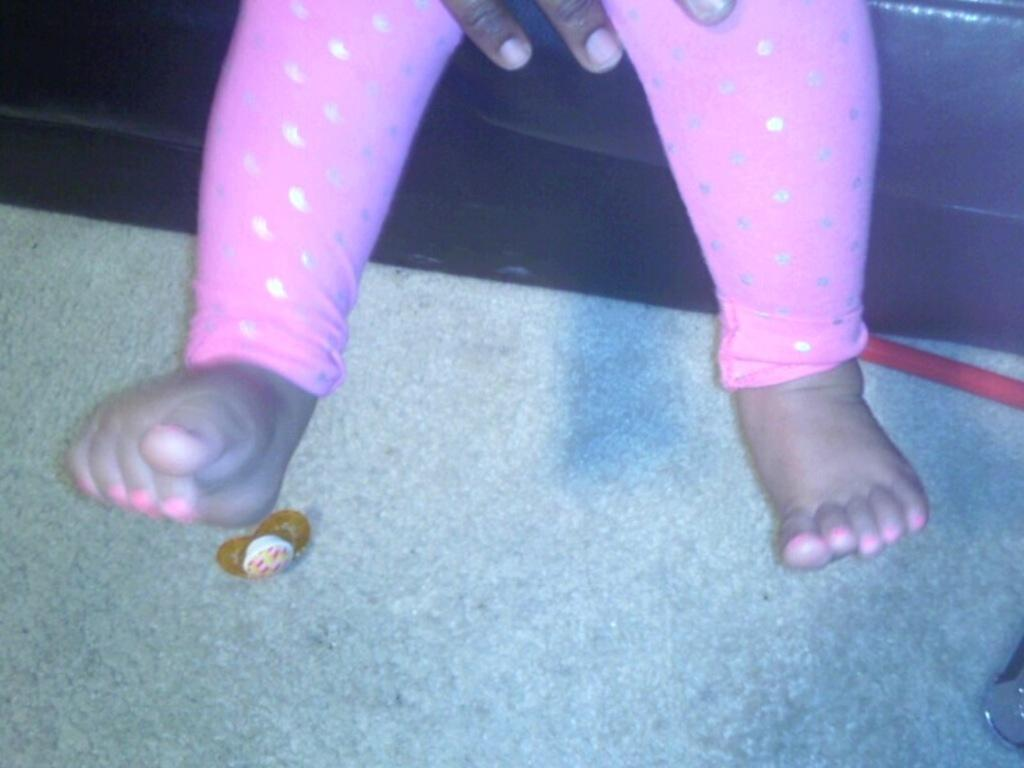What body part is visible in the image? There are a person's legs visible in the image. How many fingers can be seen in the image? There are three hand fingers visible in the image. What is on the floor in the image? There are objects on the floor in the image. What type of furniture is present in the image? There is a sofa in the image. Can you hear the person's ear in the image? There is no ear visible in the image, and it is not possible to hear an ear. 